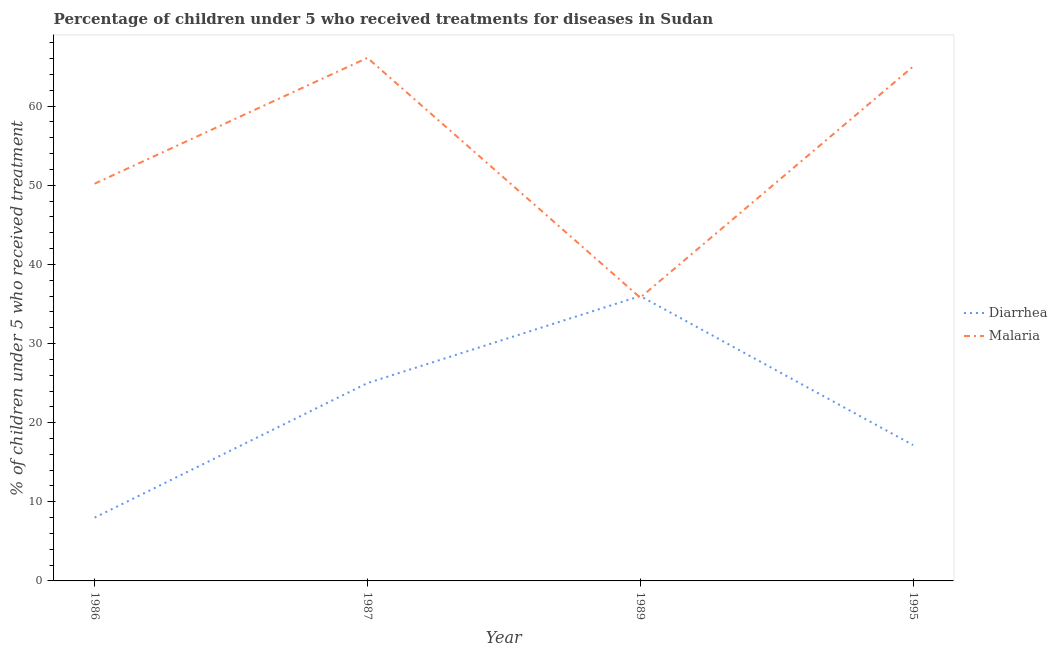How many different coloured lines are there?
Offer a terse response. 2. What is the percentage of children who received treatment for malaria in 1995?
Offer a very short reply. 65. Across all years, what is the maximum percentage of children who received treatment for malaria?
Ensure brevity in your answer.  66.1. Across all years, what is the minimum percentage of children who received treatment for malaria?
Provide a succinct answer. 35.8. What is the total percentage of children who received treatment for malaria in the graph?
Ensure brevity in your answer.  217.1. What is the difference between the percentage of children who received treatment for malaria in 1987 and that in 1989?
Offer a terse response. 30.3. What is the difference between the percentage of children who received treatment for malaria in 1986 and the percentage of children who received treatment for diarrhoea in 1987?
Make the answer very short. 25.2. What is the average percentage of children who received treatment for diarrhoea per year?
Ensure brevity in your answer.  21.54. In the year 1995, what is the difference between the percentage of children who received treatment for diarrhoea and percentage of children who received treatment for malaria?
Your response must be concise. -47.83. What is the ratio of the percentage of children who received treatment for malaria in 1986 to that in 1995?
Keep it short and to the point. 0.77. Is the percentage of children who received treatment for diarrhoea in 1989 less than that in 1995?
Provide a succinct answer. No. What is the difference between the highest and the second highest percentage of children who received treatment for malaria?
Make the answer very short. 1.1. What is the difference between the highest and the lowest percentage of children who received treatment for malaria?
Your answer should be compact. 30.3. In how many years, is the percentage of children who received treatment for malaria greater than the average percentage of children who received treatment for malaria taken over all years?
Make the answer very short. 2. Is the sum of the percentage of children who received treatment for diarrhoea in 1987 and 1995 greater than the maximum percentage of children who received treatment for malaria across all years?
Ensure brevity in your answer.  No. Is the percentage of children who received treatment for diarrhoea strictly greater than the percentage of children who received treatment for malaria over the years?
Make the answer very short. No. Is the percentage of children who received treatment for diarrhoea strictly less than the percentage of children who received treatment for malaria over the years?
Give a very brief answer. No. How many lines are there?
Your response must be concise. 2. Where does the legend appear in the graph?
Give a very brief answer. Center right. How are the legend labels stacked?
Your answer should be very brief. Vertical. What is the title of the graph?
Your response must be concise. Percentage of children under 5 who received treatments for diseases in Sudan. Does "Merchandise imports" appear as one of the legend labels in the graph?
Ensure brevity in your answer.  No. What is the label or title of the Y-axis?
Provide a succinct answer. % of children under 5 who received treatment. What is the % of children under 5 who received treatment of Malaria in 1986?
Give a very brief answer. 50.2. What is the % of children under 5 who received treatment of Malaria in 1987?
Offer a very short reply. 66.1. What is the % of children under 5 who received treatment of Malaria in 1989?
Offer a terse response. 35.8. What is the % of children under 5 who received treatment of Diarrhea in 1995?
Keep it short and to the point. 17.17. What is the % of children under 5 who received treatment of Malaria in 1995?
Ensure brevity in your answer.  65. Across all years, what is the maximum % of children under 5 who received treatment of Diarrhea?
Keep it short and to the point. 36. Across all years, what is the maximum % of children under 5 who received treatment in Malaria?
Make the answer very short. 66.1. Across all years, what is the minimum % of children under 5 who received treatment of Malaria?
Ensure brevity in your answer.  35.8. What is the total % of children under 5 who received treatment in Diarrhea in the graph?
Provide a short and direct response. 86.17. What is the total % of children under 5 who received treatment in Malaria in the graph?
Your answer should be very brief. 217.1. What is the difference between the % of children under 5 who received treatment of Diarrhea in 1986 and that in 1987?
Your response must be concise. -17. What is the difference between the % of children under 5 who received treatment in Malaria in 1986 and that in 1987?
Provide a succinct answer. -15.9. What is the difference between the % of children under 5 who received treatment of Diarrhea in 1986 and that in 1989?
Provide a short and direct response. -28. What is the difference between the % of children under 5 who received treatment in Malaria in 1986 and that in 1989?
Your response must be concise. 14.4. What is the difference between the % of children under 5 who received treatment of Diarrhea in 1986 and that in 1995?
Your answer should be very brief. -9.17. What is the difference between the % of children under 5 who received treatment of Malaria in 1986 and that in 1995?
Keep it short and to the point. -14.8. What is the difference between the % of children under 5 who received treatment in Diarrhea in 1987 and that in 1989?
Offer a terse response. -11. What is the difference between the % of children under 5 who received treatment in Malaria in 1987 and that in 1989?
Your answer should be very brief. 30.3. What is the difference between the % of children under 5 who received treatment of Diarrhea in 1987 and that in 1995?
Your answer should be compact. 7.83. What is the difference between the % of children under 5 who received treatment of Diarrhea in 1989 and that in 1995?
Provide a succinct answer. 18.83. What is the difference between the % of children under 5 who received treatment of Malaria in 1989 and that in 1995?
Make the answer very short. -29.2. What is the difference between the % of children under 5 who received treatment in Diarrhea in 1986 and the % of children under 5 who received treatment in Malaria in 1987?
Ensure brevity in your answer.  -58.1. What is the difference between the % of children under 5 who received treatment of Diarrhea in 1986 and the % of children under 5 who received treatment of Malaria in 1989?
Your response must be concise. -27.8. What is the difference between the % of children under 5 who received treatment in Diarrhea in 1986 and the % of children under 5 who received treatment in Malaria in 1995?
Offer a terse response. -57. What is the difference between the % of children under 5 who received treatment in Diarrhea in 1987 and the % of children under 5 who received treatment in Malaria in 1995?
Ensure brevity in your answer.  -40. What is the difference between the % of children under 5 who received treatment in Diarrhea in 1989 and the % of children under 5 who received treatment in Malaria in 1995?
Your answer should be very brief. -29. What is the average % of children under 5 who received treatment in Diarrhea per year?
Provide a succinct answer. 21.54. What is the average % of children under 5 who received treatment in Malaria per year?
Ensure brevity in your answer.  54.27. In the year 1986, what is the difference between the % of children under 5 who received treatment in Diarrhea and % of children under 5 who received treatment in Malaria?
Provide a succinct answer. -42.2. In the year 1987, what is the difference between the % of children under 5 who received treatment in Diarrhea and % of children under 5 who received treatment in Malaria?
Your answer should be very brief. -41.1. In the year 1989, what is the difference between the % of children under 5 who received treatment in Diarrhea and % of children under 5 who received treatment in Malaria?
Your answer should be very brief. 0.2. In the year 1995, what is the difference between the % of children under 5 who received treatment in Diarrhea and % of children under 5 who received treatment in Malaria?
Provide a succinct answer. -47.83. What is the ratio of the % of children under 5 who received treatment in Diarrhea in 1986 to that in 1987?
Keep it short and to the point. 0.32. What is the ratio of the % of children under 5 who received treatment in Malaria in 1986 to that in 1987?
Your answer should be very brief. 0.76. What is the ratio of the % of children under 5 who received treatment in Diarrhea in 1986 to that in 1989?
Offer a very short reply. 0.22. What is the ratio of the % of children under 5 who received treatment in Malaria in 1986 to that in 1989?
Offer a very short reply. 1.4. What is the ratio of the % of children under 5 who received treatment of Diarrhea in 1986 to that in 1995?
Give a very brief answer. 0.47. What is the ratio of the % of children under 5 who received treatment in Malaria in 1986 to that in 1995?
Provide a succinct answer. 0.77. What is the ratio of the % of children under 5 who received treatment in Diarrhea in 1987 to that in 1989?
Make the answer very short. 0.69. What is the ratio of the % of children under 5 who received treatment in Malaria in 1987 to that in 1989?
Provide a short and direct response. 1.85. What is the ratio of the % of children under 5 who received treatment of Diarrhea in 1987 to that in 1995?
Your answer should be compact. 1.46. What is the ratio of the % of children under 5 who received treatment in Malaria in 1987 to that in 1995?
Offer a very short reply. 1.02. What is the ratio of the % of children under 5 who received treatment in Diarrhea in 1989 to that in 1995?
Provide a succinct answer. 2.1. What is the ratio of the % of children under 5 who received treatment in Malaria in 1989 to that in 1995?
Your response must be concise. 0.55. What is the difference between the highest and the second highest % of children under 5 who received treatment in Malaria?
Your answer should be very brief. 1.1. What is the difference between the highest and the lowest % of children under 5 who received treatment of Diarrhea?
Provide a short and direct response. 28. What is the difference between the highest and the lowest % of children under 5 who received treatment of Malaria?
Ensure brevity in your answer.  30.3. 